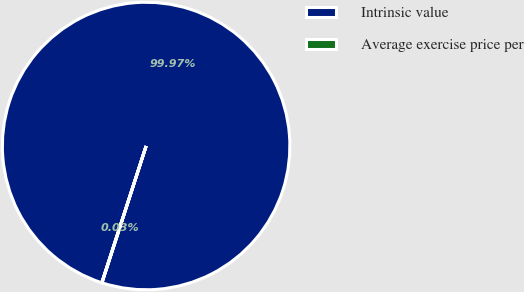Convert chart. <chart><loc_0><loc_0><loc_500><loc_500><pie_chart><fcel>Intrinsic value<fcel>Average exercise price per<nl><fcel>99.97%<fcel>0.03%<nl></chart> 